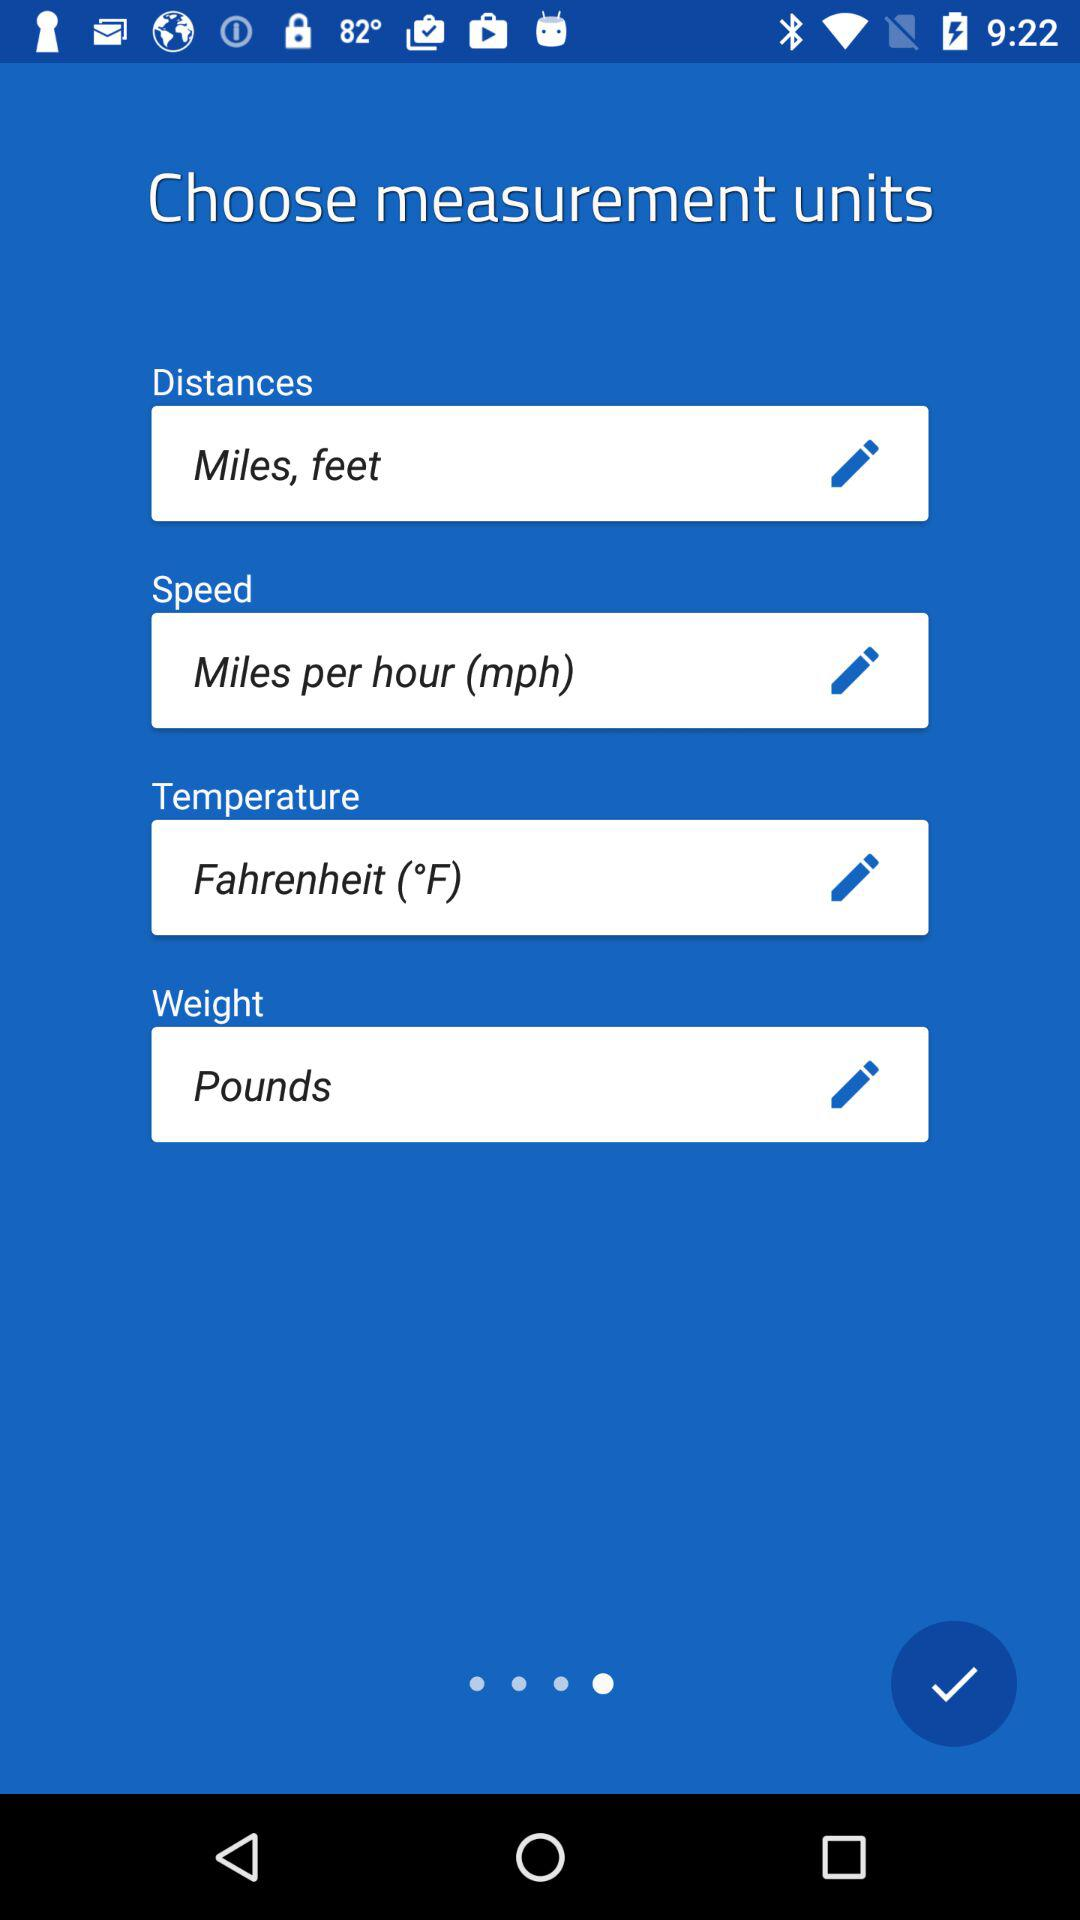What is the unit of speed? The unit of speed is miles per hour (mph). 